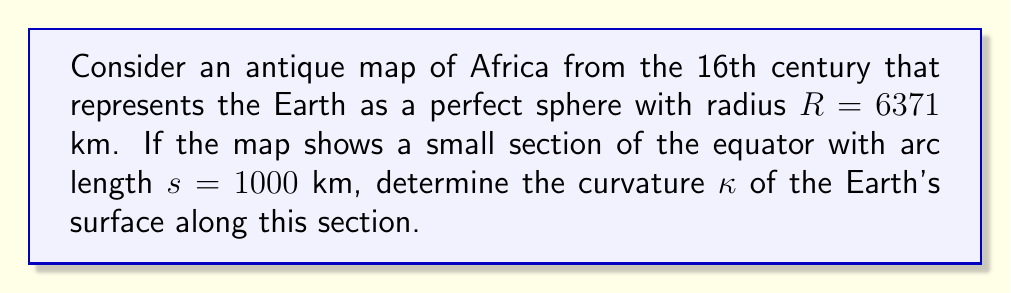Could you help me with this problem? To solve this problem, we'll follow these steps:

1) The curvature $\kappa$ of a circle (or a sphere in a great circle) is the reciprocal of its radius:

   $$\kappa = \frac{1}{R}$$

2) However, we need to verify if the given arc length is small enough to consider the curvature constant. We can do this by calculating the central angle $\theta$ (in radians) subtended by the arc:

   $$\theta = \frac{s}{R} = \frac{1000 \text{ km}}{6371 \text{ km}} \approx 0.157 \text{ radians}$$

3) This angle is approximately 9°, which is relatively small. Therefore, we can consider the curvature to be constant along this arc.

4) Now, we can simply calculate the curvature by substituting the given radius into the formula:

   $$\kappa = \frac{1}{R} = \frac{1}{6371 \text{ km}} \approx 1.57 \times 10^{-4} \text{ km}^{-1}$$

5) To express this in standard units, we convert km^(-1) to m^(-1):

   $$\kappa \approx 1.57 \times 10^{-4} \text{ km}^{-1} = 1.57 \times 10^{-7} \text{ m}^{-1}$$

This curvature value represents how quickly the Earth's surface deviates from a flat plane, as depicted on the antique map.
Answer: $1.57 \times 10^{-7} \text{ m}^{-1}$ 